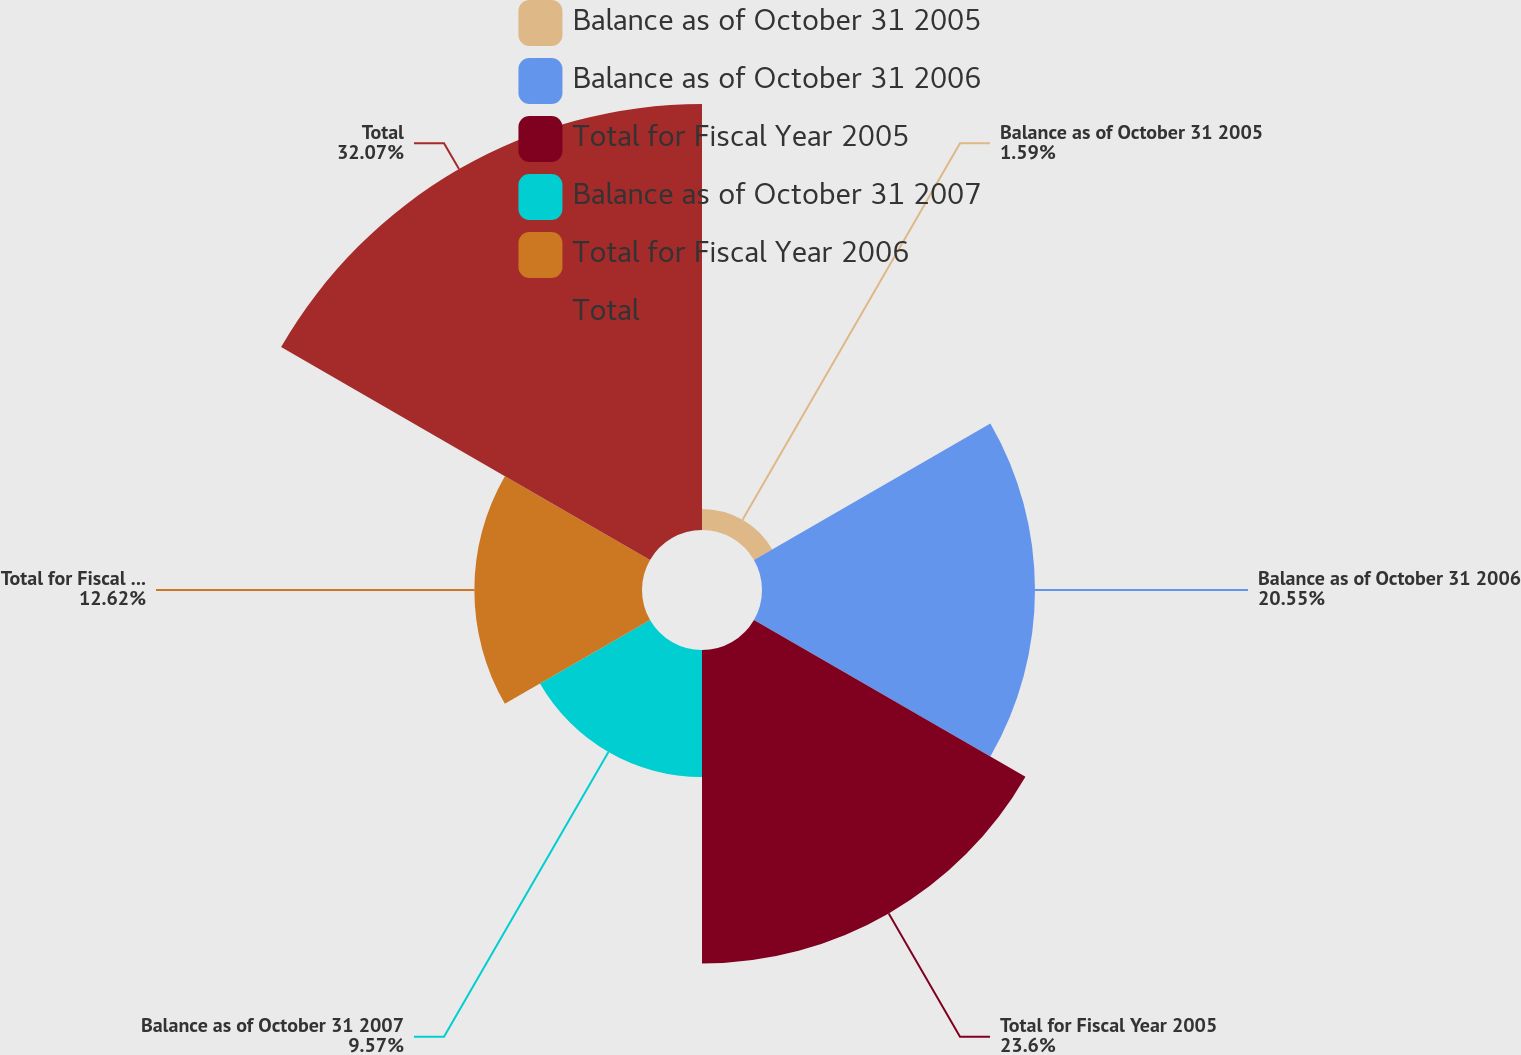Convert chart. <chart><loc_0><loc_0><loc_500><loc_500><pie_chart><fcel>Balance as of October 31 2005<fcel>Balance as of October 31 2006<fcel>Total for Fiscal Year 2005<fcel>Balance as of October 31 2007<fcel>Total for Fiscal Year 2006<fcel>Total<nl><fcel>1.59%<fcel>20.55%<fcel>23.6%<fcel>9.57%<fcel>12.62%<fcel>32.07%<nl></chart> 